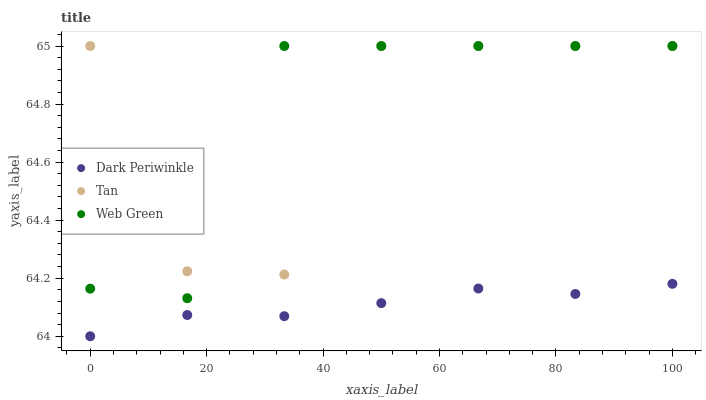Does Dark Periwinkle have the minimum area under the curve?
Answer yes or no. Yes. Does Web Green have the maximum area under the curve?
Answer yes or no. Yes. Does Web Green have the minimum area under the curve?
Answer yes or no. No. Does Dark Periwinkle have the maximum area under the curve?
Answer yes or no. No. Is Dark Periwinkle the smoothest?
Answer yes or no. Yes. Is Tan the roughest?
Answer yes or no. Yes. Is Web Green the smoothest?
Answer yes or no. No. Is Web Green the roughest?
Answer yes or no. No. Does Dark Periwinkle have the lowest value?
Answer yes or no. Yes. Does Web Green have the lowest value?
Answer yes or no. No. Does Web Green have the highest value?
Answer yes or no. Yes. Does Dark Periwinkle have the highest value?
Answer yes or no. No. Is Dark Periwinkle less than Web Green?
Answer yes or no. Yes. Is Tan greater than Dark Periwinkle?
Answer yes or no. Yes. Does Web Green intersect Tan?
Answer yes or no. Yes. Is Web Green less than Tan?
Answer yes or no. No. Is Web Green greater than Tan?
Answer yes or no. No. Does Dark Periwinkle intersect Web Green?
Answer yes or no. No. 